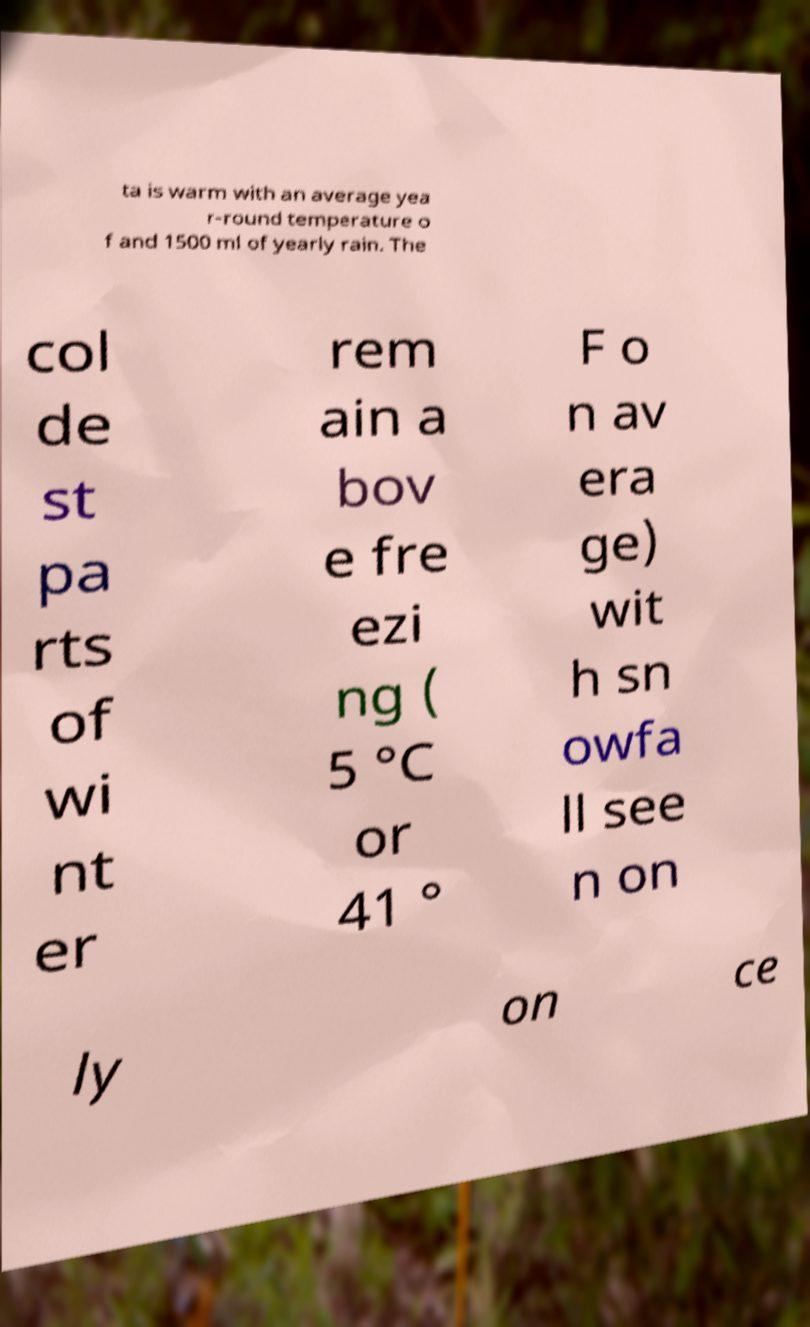Please read and relay the text visible in this image. What does it say? ta is warm with an average yea r-round temperature o f and 1500 ml of yearly rain. The col de st pa rts of wi nt er rem ain a bov e fre ezi ng ( 5 °C or 41 ° F o n av era ge) wit h sn owfa ll see n on ly on ce 